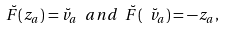<formula> <loc_0><loc_0><loc_500><loc_500>\ \breve { F } ( z _ { a } ) = \breve { v } _ { a } \ a n d \ \breve { F } ( \ \breve { v } _ { a } ) = - z _ { a } ,</formula> 